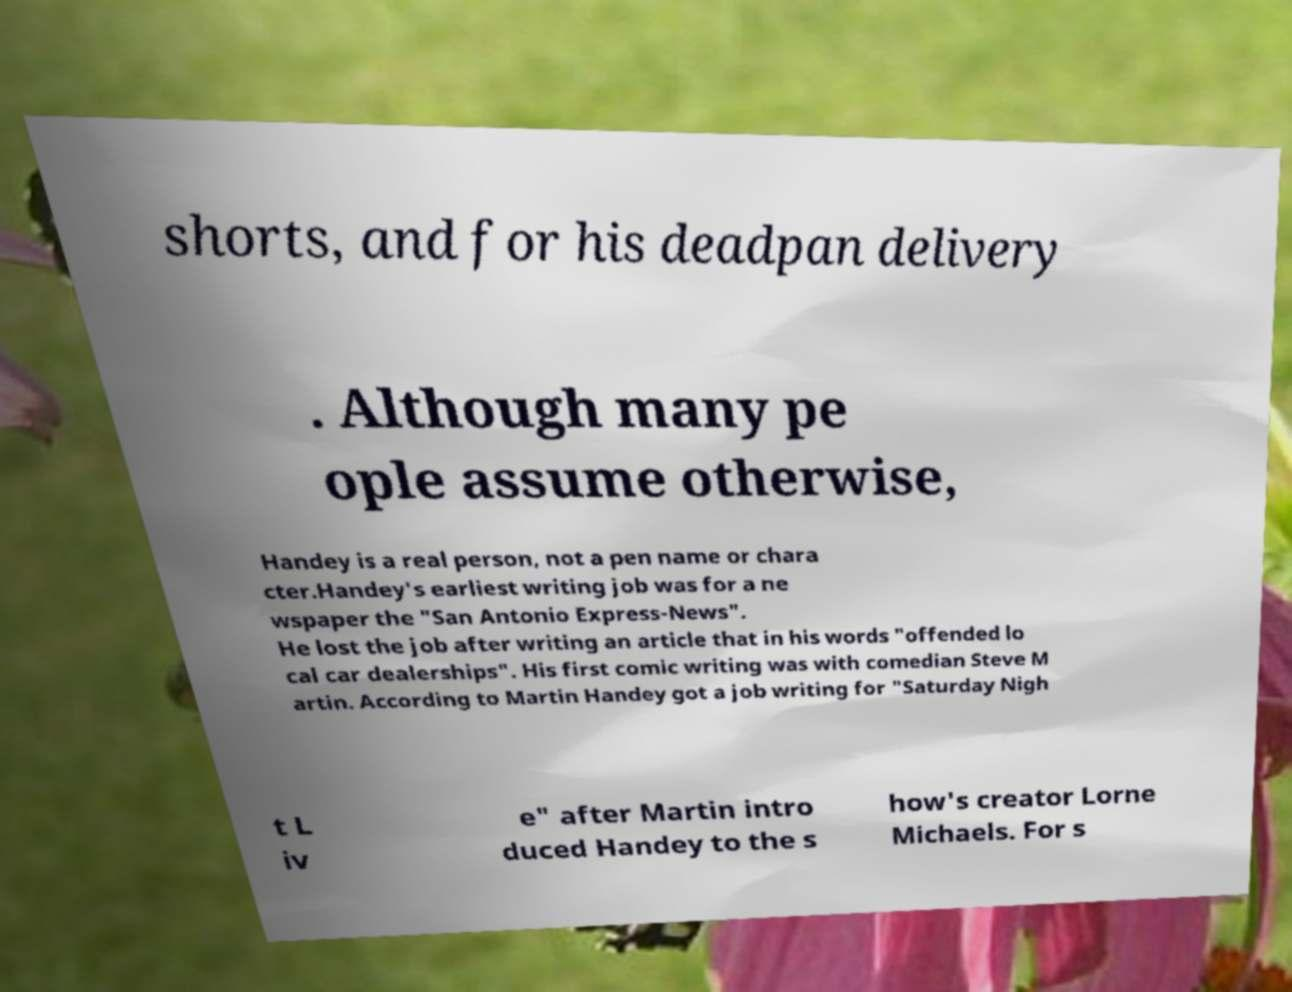I need the written content from this picture converted into text. Can you do that? shorts, and for his deadpan delivery . Although many pe ople assume otherwise, Handey is a real person, not a pen name or chara cter.Handey's earliest writing job was for a ne wspaper the "San Antonio Express-News". He lost the job after writing an article that in his words "offended lo cal car dealerships". His first comic writing was with comedian Steve M artin. According to Martin Handey got a job writing for "Saturday Nigh t L iv e" after Martin intro duced Handey to the s how's creator Lorne Michaels. For s 